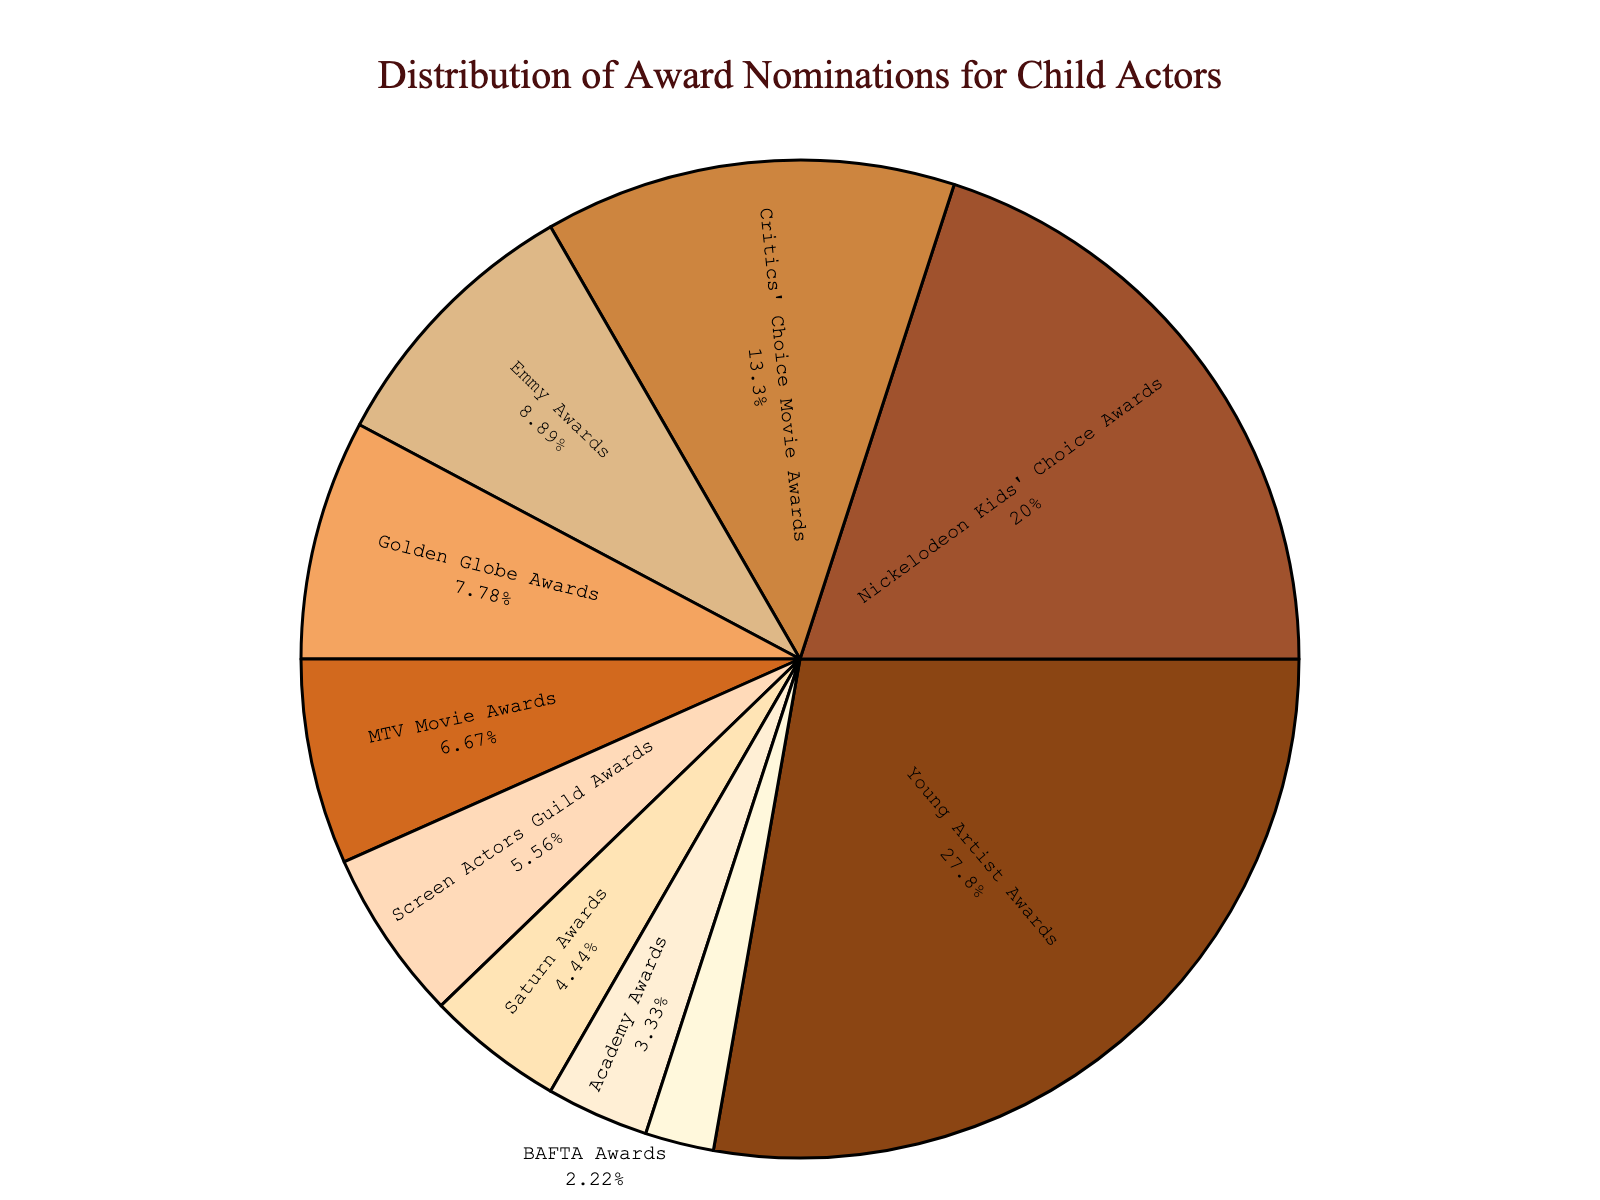What's the category with the highest percentage of nominations? The figure shows each category and its percentage of total nominations. The largest segment corresponds to the "Young Artist Awards."
Answer: Young Artist Awards Which category received more nominations: Academy Awards or Saturn Awards? From the pie chart, the segment corresponding to the "Saturn Awards" is larger than that of the "Academy Awards," indicating it received more nominations.
Answer: Saturn Awards What percent of total nominations do the Critics' Choice Movie Awards and Golden Globe Awards categories combined represent? The Critics' Choice Movie Awards have 12% and the Golden Globe Awards have 7%. Adding these percentages gives 19%.
Answer: 19% How many more nominations do the Emmy Awards have compared to the BAFTA Awards? The figure shows the number of nominations for each category. The Emmy Awards have 8 nominations, and BAFTA Awards have 2 nominations. Subtracting 2 from 8 gives 6 more nominations for the Emmy Awards.
Answer: 6 Which category has a darker color shading: MTV Movie Awards or Critics' Choice Movie Awards? From the visual attributes of the pie chart, the Critics' Choice Movie Awards segment has the darker shading compared to the MTV Movie Awards.
Answer: Critics' Choice Movie Awards If you combine the nominees for the Nickelodeon Kids' Choice Awards and Young Artist Awards, what percent of the total nominations would that be? The Nickelodeon Kids' Choice Awards have 18% and the Young Artist Awards have 25%. Adding these gives 43%.
Answer: 43% What is the difference in the percentage of nominations between the Golden Globe Awards and the Screen Actors Guild Awards? The Golden Globe Awards have 7% and the Screen Actors Guild Awards have 5%. Subtracting 5% from 7% gives a difference of 2%.
Answer: 2% From the chart, which category received the lowest percentage of nominations? The smallest segment on the pie chart corresponds to the "BAFTA Awards".
Answer: BAFTA Awards 